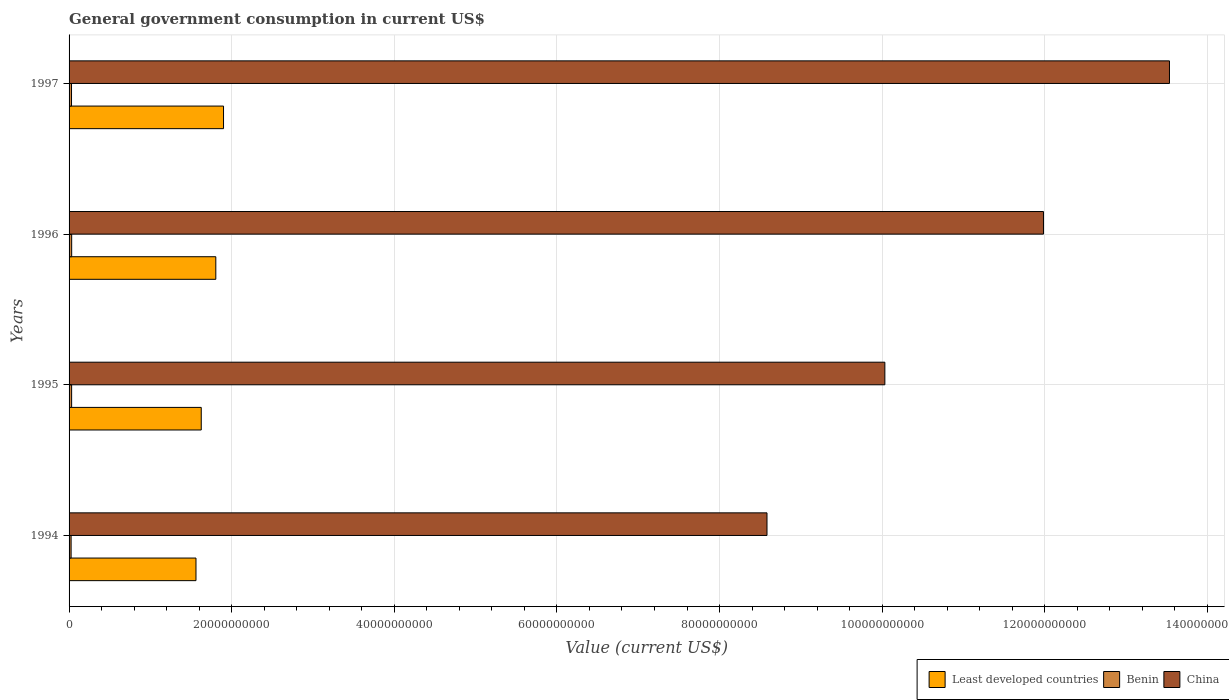How many different coloured bars are there?
Make the answer very short. 3. Are the number of bars per tick equal to the number of legend labels?
Offer a very short reply. Yes. How many bars are there on the 1st tick from the top?
Keep it short and to the point. 3. How many bars are there on the 3rd tick from the bottom?
Give a very brief answer. 3. What is the label of the 2nd group of bars from the top?
Ensure brevity in your answer.  1996. What is the government conusmption in Benin in 1995?
Offer a very short reply. 3.13e+08. Across all years, what is the maximum government conusmption in Least developed countries?
Your response must be concise. 1.90e+1. Across all years, what is the minimum government conusmption in Benin?
Provide a succinct answer. 2.50e+08. In which year was the government conusmption in China minimum?
Your response must be concise. 1994. What is the total government conusmption in Least developed countries in the graph?
Ensure brevity in your answer.  6.89e+1. What is the difference between the government conusmption in China in 1995 and that in 1997?
Keep it short and to the point. -3.50e+1. What is the difference between the government conusmption in Least developed countries in 1994 and the government conusmption in Benin in 1997?
Offer a very short reply. 1.53e+1. What is the average government conusmption in Least developed countries per year?
Provide a succinct answer. 1.72e+1. In the year 1995, what is the difference between the government conusmption in China and government conusmption in Benin?
Ensure brevity in your answer.  1.00e+11. What is the ratio of the government conusmption in Least developed countries in 1996 to that in 1997?
Ensure brevity in your answer.  0.95. Is the government conusmption in Least developed countries in 1994 less than that in 1996?
Give a very brief answer. Yes. Is the difference between the government conusmption in China in 1994 and 1997 greater than the difference between the government conusmption in Benin in 1994 and 1997?
Your answer should be compact. No. What is the difference between the highest and the second highest government conusmption in China?
Offer a terse response. 1.55e+1. What is the difference between the highest and the lowest government conusmption in Benin?
Your answer should be very brief. 6.92e+07. In how many years, is the government conusmption in China greater than the average government conusmption in China taken over all years?
Your response must be concise. 2. Is the sum of the government conusmption in Least developed countries in 1996 and 1997 greater than the maximum government conusmption in Benin across all years?
Make the answer very short. Yes. What does the 1st bar from the top in 1997 represents?
Your response must be concise. China. What does the 1st bar from the bottom in 1994 represents?
Keep it short and to the point. Least developed countries. Is it the case that in every year, the sum of the government conusmption in Benin and government conusmption in China is greater than the government conusmption in Least developed countries?
Your answer should be very brief. Yes. How many bars are there?
Keep it short and to the point. 12. Are all the bars in the graph horizontal?
Keep it short and to the point. Yes. What is the difference between two consecutive major ticks on the X-axis?
Provide a short and direct response. 2.00e+1. Does the graph contain any zero values?
Ensure brevity in your answer.  No. Does the graph contain grids?
Offer a very short reply. Yes. What is the title of the graph?
Ensure brevity in your answer.  General government consumption in current US$. Does "Fragile and conflict affected situations" appear as one of the legend labels in the graph?
Your answer should be very brief. No. What is the label or title of the X-axis?
Provide a succinct answer. Value (current US$). What is the label or title of the Y-axis?
Your response must be concise. Years. What is the Value (current US$) of Least developed countries in 1994?
Offer a terse response. 1.56e+1. What is the Value (current US$) in Benin in 1994?
Your response must be concise. 2.50e+08. What is the Value (current US$) in China in 1994?
Keep it short and to the point. 8.58e+1. What is the Value (current US$) in Least developed countries in 1995?
Provide a short and direct response. 1.63e+1. What is the Value (current US$) of Benin in 1995?
Provide a succinct answer. 3.13e+08. What is the Value (current US$) of China in 1995?
Your answer should be very brief. 1.00e+11. What is the Value (current US$) of Least developed countries in 1996?
Offer a very short reply. 1.80e+1. What is the Value (current US$) of Benin in 1996?
Make the answer very short. 3.19e+08. What is the Value (current US$) in China in 1996?
Keep it short and to the point. 1.20e+11. What is the Value (current US$) in Least developed countries in 1997?
Offer a very short reply. 1.90e+1. What is the Value (current US$) of Benin in 1997?
Provide a succinct answer. 3.00e+08. What is the Value (current US$) of China in 1997?
Your response must be concise. 1.35e+11. Across all years, what is the maximum Value (current US$) of Least developed countries?
Ensure brevity in your answer.  1.90e+1. Across all years, what is the maximum Value (current US$) of Benin?
Your response must be concise. 3.19e+08. Across all years, what is the maximum Value (current US$) of China?
Make the answer very short. 1.35e+11. Across all years, what is the minimum Value (current US$) in Least developed countries?
Give a very brief answer. 1.56e+1. Across all years, what is the minimum Value (current US$) of Benin?
Offer a very short reply. 2.50e+08. Across all years, what is the minimum Value (current US$) in China?
Your answer should be compact. 8.58e+1. What is the total Value (current US$) of Least developed countries in the graph?
Keep it short and to the point. 6.89e+1. What is the total Value (current US$) of Benin in the graph?
Give a very brief answer. 1.18e+09. What is the total Value (current US$) in China in the graph?
Your response must be concise. 4.41e+11. What is the difference between the Value (current US$) in Least developed countries in 1994 and that in 1995?
Provide a succinct answer. -6.48e+08. What is the difference between the Value (current US$) of Benin in 1994 and that in 1995?
Keep it short and to the point. -6.36e+07. What is the difference between the Value (current US$) of China in 1994 and that in 1995?
Give a very brief answer. -1.45e+1. What is the difference between the Value (current US$) in Least developed countries in 1994 and that in 1996?
Your response must be concise. -2.44e+09. What is the difference between the Value (current US$) in Benin in 1994 and that in 1996?
Your response must be concise. -6.92e+07. What is the difference between the Value (current US$) of China in 1994 and that in 1996?
Make the answer very short. -3.40e+1. What is the difference between the Value (current US$) in Least developed countries in 1994 and that in 1997?
Provide a short and direct response. -3.39e+09. What is the difference between the Value (current US$) in Benin in 1994 and that in 1997?
Your response must be concise. -4.99e+07. What is the difference between the Value (current US$) in China in 1994 and that in 1997?
Ensure brevity in your answer.  -4.95e+1. What is the difference between the Value (current US$) of Least developed countries in 1995 and that in 1996?
Provide a short and direct response. -1.79e+09. What is the difference between the Value (current US$) of Benin in 1995 and that in 1996?
Ensure brevity in your answer.  -5.58e+06. What is the difference between the Value (current US$) in China in 1995 and that in 1996?
Ensure brevity in your answer.  -1.95e+1. What is the difference between the Value (current US$) in Least developed countries in 1995 and that in 1997?
Keep it short and to the point. -2.74e+09. What is the difference between the Value (current US$) in Benin in 1995 and that in 1997?
Offer a terse response. 1.38e+07. What is the difference between the Value (current US$) in China in 1995 and that in 1997?
Offer a very short reply. -3.50e+1. What is the difference between the Value (current US$) in Least developed countries in 1996 and that in 1997?
Ensure brevity in your answer.  -9.50e+08. What is the difference between the Value (current US$) of Benin in 1996 and that in 1997?
Offer a very short reply. 1.93e+07. What is the difference between the Value (current US$) in China in 1996 and that in 1997?
Your answer should be compact. -1.55e+1. What is the difference between the Value (current US$) of Least developed countries in 1994 and the Value (current US$) of Benin in 1995?
Your answer should be compact. 1.53e+1. What is the difference between the Value (current US$) of Least developed countries in 1994 and the Value (current US$) of China in 1995?
Make the answer very short. -8.47e+1. What is the difference between the Value (current US$) of Benin in 1994 and the Value (current US$) of China in 1995?
Keep it short and to the point. -1.00e+11. What is the difference between the Value (current US$) of Least developed countries in 1994 and the Value (current US$) of Benin in 1996?
Your response must be concise. 1.53e+1. What is the difference between the Value (current US$) in Least developed countries in 1994 and the Value (current US$) in China in 1996?
Ensure brevity in your answer.  -1.04e+11. What is the difference between the Value (current US$) of Benin in 1994 and the Value (current US$) of China in 1996?
Ensure brevity in your answer.  -1.20e+11. What is the difference between the Value (current US$) in Least developed countries in 1994 and the Value (current US$) in Benin in 1997?
Provide a short and direct response. 1.53e+1. What is the difference between the Value (current US$) in Least developed countries in 1994 and the Value (current US$) in China in 1997?
Offer a terse response. -1.20e+11. What is the difference between the Value (current US$) in Benin in 1994 and the Value (current US$) in China in 1997?
Provide a short and direct response. -1.35e+11. What is the difference between the Value (current US$) in Least developed countries in 1995 and the Value (current US$) in Benin in 1996?
Offer a terse response. 1.59e+1. What is the difference between the Value (current US$) of Least developed countries in 1995 and the Value (current US$) of China in 1996?
Make the answer very short. -1.04e+11. What is the difference between the Value (current US$) of Benin in 1995 and the Value (current US$) of China in 1996?
Give a very brief answer. -1.20e+11. What is the difference between the Value (current US$) in Least developed countries in 1995 and the Value (current US$) in Benin in 1997?
Ensure brevity in your answer.  1.60e+1. What is the difference between the Value (current US$) in Least developed countries in 1995 and the Value (current US$) in China in 1997?
Give a very brief answer. -1.19e+11. What is the difference between the Value (current US$) in Benin in 1995 and the Value (current US$) in China in 1997?
Give a very brief answer. -1.35e+11. What is the difference between the Value (current US$) of Least developed countries in 1996 and the Value (current US$) of Benin in 1997?
Offer a terse response. 1.77e+1. What is the difference between the Value (current US$) of Least developed countries in 1996 and the Value (current US$) of China in 1997?
Keep it short and to the point. -1.17e+11. What is the difference between the Value (current US$) of Benin in 1996 and the Value (current US$) of China in 1997?
Your response must be concise. -1.35e+11. What is the average Value (current US$) of Least developed countries per year?
Give a very brief answer. 1.72e+1. What is the average Value (current US$) in Benin per year?
Make the answer very short. 2.96e+08. What is the average Value (current US$) in China per year?
Make the answer very short. 1.10e+11. In the year 1994, what is the difference between the Value (current US$) of Least developed countries and Value (current US$) of Benin?
Your answer should be compact. 1.54e+1. In the year 1994, what is the difference between the Value (current US$) in Least developed countries and Value (current US$) in China?
Give a very brief answer. -7.02e+1. In the year 1994, what is the difference between the Value (current US$) in Benin and Value (current US$) in China?
Make the answer very short. -8.56e+1. In the year 1995, what is the difference between the Value (current US$) of Least developed countries and Value (current US$) of Benin?
Ensure brevity in your answer.  1.59e+1. In the year 1995, what is the difference between the Value (current US$) of Least developed countries and Value (current US$) of China?
Make the answer very short. -8.41e+1. In the year 1995, what is the difference between the Value (current US$) in Benin and Value (current US$) in China?
Offer a very short reply. -1.00e+11. In the year 1996, what is the difference between the Value (current US$) of Least developed countries and Value (current US$) of Benin?
Your answer should be compact. 1.77e+1. In the year 1996, what is the difference between the Value (current US$) in Least developed countries and Value (current US$) in China?
Your answer should be very brief. -1.02e+11. In the year 1996, what is the difference between the Value (current US$) of Benin and Value (current US$) of China?
Your response must be concise. -1.20e+11. In the year 1997, what is the difference between the Value (current US$) in Least developed countries and Value (current US$) in Benin?
Offer a terse response. 1.87e+1. In the year 1997, what is the difference between the Value (current US$) in Least developed countries and Value (current US$) in China?
Your response must be concise. -1.16e+11. In the year 1997, what is the difference between the Value (current US$) of Benin and Value (current US$) of China?
Your answer should be compact. -1.35e+11. What is the ratio of the Value (current US$) of Least developed countries in 1994 to that in 1995?
Your answer should be compact. 0.96. What is the ratio of the Value (current US$) in Benin in 1994 to that in 1995?
Make the answer very short. 0.8. What is the ratio of the Value (current US$) in China in 1994 to that in 1995?
Offer a very short reply. 0.86. What is the ratio of the Value (current US$) in Least developed countries in 1994 to that in 1996?
Offer a very short reply. 0.86. What is the ratio of the Value (current US$) in Benin in 1994 to that in 1996?
Give a very brief answer. 0.78. What is the ratio of the Value (current US$) of China in 1994 to that in 1996?
Offer a very short reply. 0.72. What is the ratio of the Value (current US$) of Least developed countries in 1994 to that in 1997?
Ensure brevity in your answer.  0.82. What is the ratio of the Value (current US$) of Benin in 1994 to that in 1997?
Your answer should be compact. 0.83. What is the ratio of the Value (current US$) of China in 1994 to that in 1997?
Offer a terse response. 0.63. What is the ratio of the Value (current US$) of Least developed countries in 1995 to that in 1996?
Make the answer very short. 0.9. What is the ratio of the Value (current US$) in Benin in 1995 to that in 1996?
Give a very brief answer. 0.98. What is the ratio of the Value (current US$) of China in 1995 to that in 1996?
Provide a succinct answer. 0.84. What is the ratio of the Value (current US$) in Least developed countries in 1995 to that in 1997?
Your answer should be very brief. 0.86. What is the ratio of the Value (current US$) of Benin in 1995 to that in 1997?
Keep it short and to the point. 1.05. What is the ratio of the Value (current US$) in China in 1995 to that in 1997?
Your answer should be compact. 0.74. What is the ratio of the Value (current US$) in Least developed countries in 1996 to that in 1997?
Your response must be concise. 0.95. What is the ratio of the Value (current US$) in Benin in 1996 to that in 1997?
Make the answer very short. 1.06. What is the ratio of the Value (current US$) in China in 1996 to that in 1997?
Make the answer very short. 0.89. What is the difference between the highest and the second highest Value (current US$) of Least developed countries?
Your answer should be very brief. 9.50e+08. What is the difference between the highest and the second highest Value (current US$) of Benin?
Your answer should be compact. 5.58e+06. What is the difference between the highest and the second highest Value (current US$) of China?
Provide a succinct answer. 1.55e+1. What is the difference between the highest and the lowest Value (current US$) in Least developed countries?
Keep it short and to the point. 3.39e+09. What is the difference between the highest and the lowest Value (current US$) in Benin?
Make the answer very short. 6.92e+07. What is the difference between the highest and the lowest Value (current US$) of China?
Your answer should be very brief. 4.95e+1. 